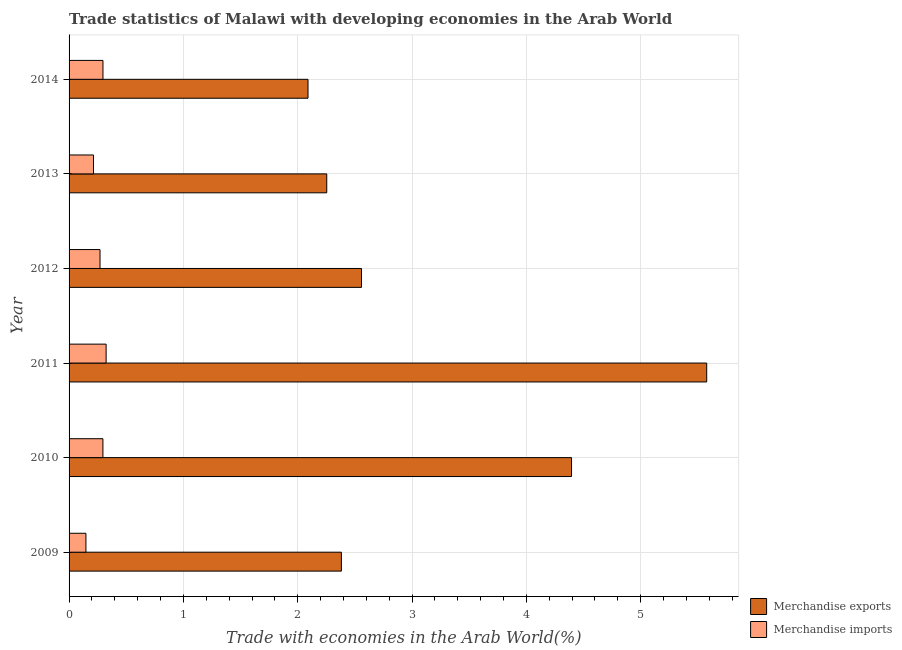How many groups of bars are there?
Give a very brief answer. 6. Are the number of bars on each tick of the Y-axis equal?
Your response must be concise. Yes. How many bars are there on the 6th tick from the top?
Ensure brevity in your answer.  2. How many bars are there on the 2nd tick from the bottom?
Your answer should be very brief. 2. What is the label of the 4th group of bars from the top?
Your answer should be compact. 2011. In how many cases, is the number of bars for a given year not equal to the number of legend labels?
Your answer should be very brief. 0. What is the merchandise imports in 2010?
Your answer should be compact. 0.3. Across all years, what is the maximum merchandise imports?
Offer a very short reply. 0.32. Across all years, what is the minimum merchandise exports?
Make the answer very short. 2.09. In which year was the merchandise exports maximum?
Give a very brief answer. 2011. In which year was the merchandise imports minimum?
Give a very brief answer. 2009. What is the total merchandise imports in the graph?
Provide a short and direct response. 1.55. What is the difference between the merchandise imports in 2009 and that in 2011?
Give a very brief answer. -0.18. What is the difference between the merchandise exports in 2009 and the merchandise imports in 2012?
Offer a very short reply. 2.11. What is the average merchandise exports per year?
Make the answer very short. 3.21. In the year 2009, what is the difference between the merchandise exports and merchandise imports?
Make the answer very short. 2.23. In how many years, is the merchandise exports greater than 1.2 %?
Ensure brevity in your answer.  6. What is the ratio of the merchandise imports in 2013 to that in 2014?
Your answer should be compact. 0.72. What is the difference between the highest and the second highest merchandise exports?
Make the answer very short. 1.18. What is the difference between the highest and the lowest merchandise exports?
Provide a succinct answer. 3.49. In how many years, is the merchandise exports greater than the average merchandise exports taken over all years?
Provide a succinct answer. 2. How many years are there in the graph?
Offer a very short reply. 6. Are the values on the major ticks of X-axis written in scientific E-notation?
Offer a terse response. No. Does the graph contain any zero values?
Give a very brief answer. No. Where does the legend appear in the graph?
Ensure brevity in your answer.  Bottom right. How many legend labels are there?
Keep it short and to the point. 2. How are the legend labels stacked?
Your response must be concise. Vertical. What is the title of the graph?
Keep it short and to the point. Trade statistics of Malawi with developing economies in the Arab World. What is the label or title of the X-axis?
Offer a terse response. Trade with economies in the Arab World(%). What is the label or title of the Y-axis?
Offer a terse response. Year. What is the Trade with economies in the Arab World(%) in Merchandise exports in 2009?
Offer a very short reply. 2.38. What is the Trade with economies in the Arab World(%) of Merchandise imports in 2009?
Provide a short and direct response. 0.15. What is the Trade with economies in the Arab World(%) in Merchandise exports in 2010?
Your response must be concise. 4.39. What is the Trade with economies in the Arab World(%) of Merchandise imports in 2010?
Make the answer very short. 0.3. What is the Trade with economies in the Arab World(%) of Merchandise exports in 2011?
Your answer should be compact. 5.58. What is the Trade with economies in the Arab World(%) of Merchandise imports in 2011?
Your response must be concise. 0.32. What is the Trade with economies in the Arab World(%) of Merchandise exports in 2012?
Offer a terse response. 2.56. What is the Trade with economies in the Arab World(%) of Merchandise imports in 2012?
Provide a succinct answer. 0.27. What is the Trade with economies in the Arab World(%) in Merchandise exports in 2013?
Provide a short and direct response. 2.25. What is the Trade with economies in the Arab World(%) of Merchandise imports in 2013?
Give a very brief answer. 0.21. What is the Trade with economies in the Arab World(%) in Merchandise exports in 2014?
Give a very brief answer. 2.09. What is the Trade with economies in the Arab World(%) in Merchandise imports in 2014?
Provide a short and direct response. 0.3. Across all years, what is the maximum Trade with economies in the Arab World(%) of Merchandise exports?
Offer a terse response. 5.58. Across all years, what is the maximum Trade with economies in the Arab World(%) in Merchandise imports?
Offer a terse response. 0.32. Across all years, what is the minimum Trade with economies in the Arab World(%) in Merchandise exports?
Offer a very short reply. 2.09. Across all years, what is the minimum Trade with economies in the Arab World(%) of Merchandise imports?
Offer a very short reply. 0.15. What is the total Trade with economies in the Arab World(%) in Merchandise exports in the graph?
Ensure brevity in your answer.  19.26. What is the total Trade with economies in the Arab World(%) in Merchandise imports in the graph?
Your answer should be compact. 1.55. What is the difference between the Trade with economies in the Arab World(%) in Merchandise exports in 2009 and that in 2010?
Provide a succinct answer. -2.01. What is the difference between the Trade with economies in the Arab World(%) of Merchandise imports in 2009 and that in 2010?
Offer a very short reply. -0.15. What is the difference between the Trade with economies in the Arab World(%) in Merchandise exports in 2009 and that in 2011?
Your response must be concise. -3.2. What is the difference between the Trade with economies in the Arab World(%) in Merchandise imports in 2009 and that in 2011?
Your answer should be very brief. -0.18. What is the difference between the Trade with economies in the Arab World(%) in Merchandise exports in 2009 and that in 2012?
Your answer should be very brief. -0.18. What is the difference between the Trade with economies in the Arab World(%) in Merchandise imports in 2009 and that in 2012?
Your answer should be very brief. -0.12. What is the difference between the Trade with economies in the Arab World(%) of Merchandise exports in 2009 and that in 2013?
Make the answer very short. 0.13. What is the difference between the Trade with economies in the Arab World(%) in Merchandise imports in 2009 and that in 2013?
Make the answer very short. -0.07. What is the difference between the Trade with economies in the Arab World(%) of Merchandise exports in 2009 and that in 2014?
Offer a very short reply. 0.29. What is the difference between the Trade with economies in the Arab World(%) in Merchandise imports in 2009 and that in 2014?
Your answer should be very brief. -0.15. What is the difference between the Trade with economies in the Arab World(%) of Merchandise exports in 2010 and that in 2011?
Your answer should be compact. -1.18. What is the difference between the Trade with economies in the Arab World(%) of Merchandise imports in 2010 and that in 2011?
Make the answer very short. -0.03. What is the difference between the Trade with economies in the Arab World(%) of Merchandise exports in 2010 and that in 2012?
Your answer should be compact. 1.84. What is the difference between the Trade with economies in the Arab World(%) in Merchandise imports in 2010 and that in 2012?
Offer a very short reply. 0.03. What is the difference between the Trade with economies in the Arab World(%) in Merchandise exports in 2010 and that in 2013?
Keep it short and to the point. 2.14. What is the difference between the Trade with economies in the Arab World(%) in Merchandise imports in 2010 and that in 2013?
Provide a succinct answer. 0.08. What is the difference between the Trade with economies in the Arab World(%) in Merchandise exports in 2010 and that in 2014?
Your answer should be compact. 2.3. What is the difference between the Trade with economies in the Arab World(%) in Merchandise imports in 2010 and that in 2014?
Ensure brevity in your answer.  -0. What is the difference between the Trade with economies in the Arab World(%) of Merchandise exports in 2011 and that in 2012?
Make the answer very short. 3.02. What is the difference between the Trade with economies in the Arab World(%) of Merchandise imports in 2011 and that in 2012?
Provide a succinct answer. 0.05. What is the difference between the Trade with economies in the Arab World(%) of Merchandise exports in 2011 and that in 2013?
Ensure brevity in your answer.  3.32. What is the difference between the Trade with economies in the Arab World(%) in Merchandise imports in 2011 and that in 2013?
Provide a succinct answer. 0.11. What is the difference between the Trade with economies in the Arab World(%) in Merchandise exports in 2011 and that in 2014?
Make the answer very short. 3.49. What is the difference between the Trade with economies in the Arab World(%) in Merchandise imports in 2011 and that in 2014?
Your answer should be very brief. 0.03. What is the difference between the Trade with economies in the Arab World(%) in Merchandise exports in 2012 and that in 2013?
Offer a terse response. 0.3. What is the difference between the Trade with economies in the Arab World(%) of Merchandise imports in 2012 and that in 2013?
Offer a terse response. 0.06. What is the difference between the Trade with economies in the Arab World(%) in Merchandise exports in 2012 and that in 2014?
Provide a succinct answer. 0.47. What is the difference between the Trade with economies in the Arab World(%) of Merchandise imports in 2012 and that in 2014?
Make the answer very short. -0.03. What is the difference between the Trade with economies in the Arab World(%) in Merchandise exports in 2013 and that in 2014?
Offer a very short reply. 0.16. What is the difference between the Trade with economies in the Arab World(%) in Merchandise imports in 2013 and that in 2014?
Offer a very short reply. -0.08. What is the difference between the Trade with economies in the Arab World(%) of Merchandise exports in 2009 and the Trade with economies in the Arab World(%) of Merchandise imports in 2010?
Offer a very short reply. 2.09. What is the difference between the Trade with economies in the Arab World(%) of Merchandise exports in 2009 and the Trade with economies in the Arab World(%) of Merchandise imports in 2011?
Offer a very short reply. 2.06. What is the difference between the Trade with economies in the Arab World(%) in Merchandise exports in 2009 and the Trade with economies in the Arab World(%) in Merchandise imports in 2012?
Ensure brevity in your answer.  2.11. What is the difference between the Trade with economies in the Arab World(%) in Merchandise exports in 2009 and the Trade with economies in the Arab World(%) in Merchandise imports in 2013?
Offer a terse response. 2.17. What is the difference between the Trade with economies in the Arab World(%) in Merchandise exports in 2009 and the Trade with economies in the Arab World(%) in Merchandise imports in 2014?
Your answer should be compact. 2.09. What is the difference between the Trade with economies in the Arab World(%) of Merchandise exports in 2010 and the Trade with economies in the Arab World(%) of Merchandise imports in 2011?
Give a very brief answer. 4.07. What is the difference between the Trade with economies in the Arab World(%) of Merchandise exports in 2010 and the Trade with economies in the Arab World(%) of Merchandise imports in 2012?
Offer a terse response. 4.12. What is the difference between the Trade with economies in the Arab World(%) of Merchandise exports in 2010 and the Trade with economies in the Arab World(%) of Merchandise imports in 2013?
Your response must be concise. 4.18. What is the difference between the Trade with economies in the Arab World(%) of Merchandise exports in 2010 and the Trade with economies in the Arab World(%) of Merchandise imports in 2014?
Make the answer very short. 4.1. What is the difference between the Trade with economies in the Arab World(%) of Merchandise exports in 2011 and the Trade with economies in the Arab World(%) of Merchandise imports in 2012?
Provide a short and direct response. 5.31. What is the difference between the Trade with economies in the Arab World(%) of Merchandise exports in 2011 and the Trade with economies in the Arab World(%) of Merchandise imports in 2013?
Keep it short and to the point. 5.36. What is the difference between the Trade with economies in the Arab World(%) of Merchandise exports in 2011 and the Trade with economies in the Arab World(%) of Merchandise imports in 2014?
Make the answer very short. 5.28. What is the difference between the Trade with economies in the Arab World(%) in Merchandise exports in 2012 and the Trade with economies in the Arab World(%) in Merchandise imports in 2013?
Give a very brief answer. 2.34. What is the difference between the Trade with economies in the Arab World(%) in Merchandise exports in 2012 and the Trade with economies in the Arab World(%) in Merchandise imports in 2014?
Your answer should be very brief. 2.26. What is the difference between the Trade with economies in the Arab World(%) of Merchandise exports in 2013 and the Trade with economies in the Arab World(%) of Merchandise imports in 2014?
Give a very brief answer. 1.96. What is the average Trade with economies in the Arab World(%) of Merchandise exports per year?
Offer a terse response. 3.21. What is the average Trade with economies in the Arab World(%) in Merchandise imports per year?
Offer a very short reply. 0.26. In the year 2009, what is the difference between the Trade with economies in the Arab World(%) in Merchandise exports and Trade with economies in the Arab World(%) in Merchandise imports?
Offer a very short reply. 2.23. In the year 2010, what is the difference between the Trade with economies in the Arab World(%) of Merchandise exports and Trade with economies in the Arab World(%) of Merchandise imports?
Offer a terse response. 4.1. In the year 2011, what is the difference between the Trade with economies in the Arab World(%) in Merchandise exports and Trade with economies in the Arab World(%) in Merchandise imports?
Your answer should be compact. 5.25. In the year 2012, what is the difference between the Trade with economies in the Arab World(%) in Merchandise exports and Trade with economies in the Arab World(%) in Merchandise imports?
Make the answer very short. 2.29. In the year 2013, what is the difference between the Trade with economies in the Arab World(%) of Merchandise exports and Trade with economies in the Arab World(%) of Merchandise imports?
Your answer should be compact. 2.04. In the year 2014, what is the difference between the Trade with economies in the Arab World(%) of Merchandise exports and Trade with economies in the Arab World(%) of Merchandise imports?
Your answer should be very brief. 1.79. What is the ratio of the Trade with economies in the Arab World(%) of Merchandise exports in 2009 to that in 2010?
Your answer should be compact. 0.54. What is the ratio of the Trade with economies in the Arab World(%) in Merchandise imports in 2009 to that in 2010?
Offer a terse response. 0.5. What is the ratio of the Trade with economies in the Arab World(%) in Merchandise exports in 2009 to that in 2011?
Provide a short and direct response. 0.43. What is the ratio of the Trade with economies in the Arab World(%) of Merchandise imports in 2009 to that in 2011?
Provide a short and direct response. 0.46. What is the ratio of the Trade with economies in the Arab World(%) in Merchandise exports in 2009 to that in 2012?
Your response must be concise. 0.93. What is the ratio of the Trade with economies in the Arab World(%) of Merchandise imports in 2009 to that in 2012?
Provide a succinct answer. 0.55. What is the ratio of the Trade with economies in the Arab World(%) of Merchandise exports in 2009 to that in 2013?
Offer a very short reply. 1.06. What is the ratio of the Trade with economies in the Arab World(%) in Merchandise imports in 2009 to that in 2013?
Give a very brief answer. 0.69. What is the ratio of the Trade with economies in the Arab World(%) of Merchandise exports in 2009 to that in 2014?
Your answer should be compact. 1.14. What is the ratio of the Trade with economies in the Arab World(%) in Merchandise imports in 2009 to that in 2014?
Your response must be concise. 0.5. What is the ratio of the Trade with economies in the Arab World(%) of Merchandise exports in 2010 to that in 2011?
Provide a short and direct response. 0.79. What is the ratio of the Trade with economies in the Arab World(%) in Merchandise imports in 2010 to that in 2011?
Your answer should be very brief. 0.91. What is the ratio of the Trade with economies in the Arab World(%) of Merchandise exports in 2010 to that in 2012?
Offer a very short reply. 1.72. What is the ratio of the Trade with economies in the Arab World(%) of Merchandise imports in 2010 to that in 2012?
Offer a very short reply. 1.09. What is the ratio of the Trade with economies in the Arab World(%) in Merchandise exports in 2010 to that in 2013?
Your response must be concise. 1.95. What is the ratio of the Trade with economies in the Arab World(%) of Merchandise imports in 2010 to that in 2013?
Provide a short and direct response. 1.39. What is the ratio of the Trade with economies in the Arab World(%) of Merchandise exports in 2010 to that in 2014?
Ensure brevity in your answer.  2.1. What is the ratio of the Trade with economies in the Arab World(%) of Merchandise imports in 2010 to that in 2014?
Keep it short and to the point. 1. What is the ratio of the Trade with economies in the Arab World(%) in Merchandise exports in 2011 to that in 2012?
Give a very brief answer. 2.18. What is the ratio of the Trade with economies in the Arab World(%) in Merchandise imports in 2011 to that in 2012?
Your answer should be very brief. 1.2. What is the ratio of the Trade with economies in the Arab World(%) of Merchandise exports in 2011 to that in 2013?
Make the answer very short. 2.47. What is the ratio of the Trade with economies in the Arab World(%) of Merchandise imports in 2011 to that in 2013?
Make the answer very short. 1.52. What is the ratio of the Trade with economies in the Arab World(%) of Merchandise exports in 2011 to that in 2014?
Keep it short and to the point. 2.67. What is the ratio of the Trade with economies in the Arab World(%) in Merchandise imports in 2011 to that in 2014?
Provide a short and direct response. 1.09. What is the ratio of the Trade with economies in the Arab World(%) in Merchandise exports in 2012 to that in 2013?
Your answer should be very brief. 1.13. What is the ratio of the Trade with economies in the Arab World(%) of Merchandise imports in 2012 to that in 2013?
Make the answer very short. 1.27. What is the ratio of the Trade with economies in the Arab World(%) of Merchandise exports in 2012 to that in 2014?
Keep it short and to the point. 1.22. What is the ratio of the Trade with economies in the Arab World(%) of Merchandise imports in 2012 to that in 2014?
Keep it short and to the point. 0.91. What is the ratio of the Trade with economies in the Arab World(%) in Merchandise exports in 2013 to that in 2014?
Your response must be concise. 1.08. What is the ratio of the Trade with economies in the Arab World(%) in Merchandise imports in 2013 to that in 2014?
Keep it short and to the point. 0.72. What is the difference between the highest and the second highest Trade with economies in the Arab World(%) in Merchandise exports?
Offer a very short reply. 1.18. What is the difference between the highest and the second highest Trade with economies in the Arab World(%) in Merchandise imports?
Your answer should be very brief. 0.03. What is the difference between the highest and the lowest Trade with economies in the Arab World(%) of Merchandise exports?
Your answer should be compact. 3.49. What is the difference between the highest and the lowest Trade with economies in the Arab World(%) of Merchandise imports?
Keep it short and to the point. 0.18. 